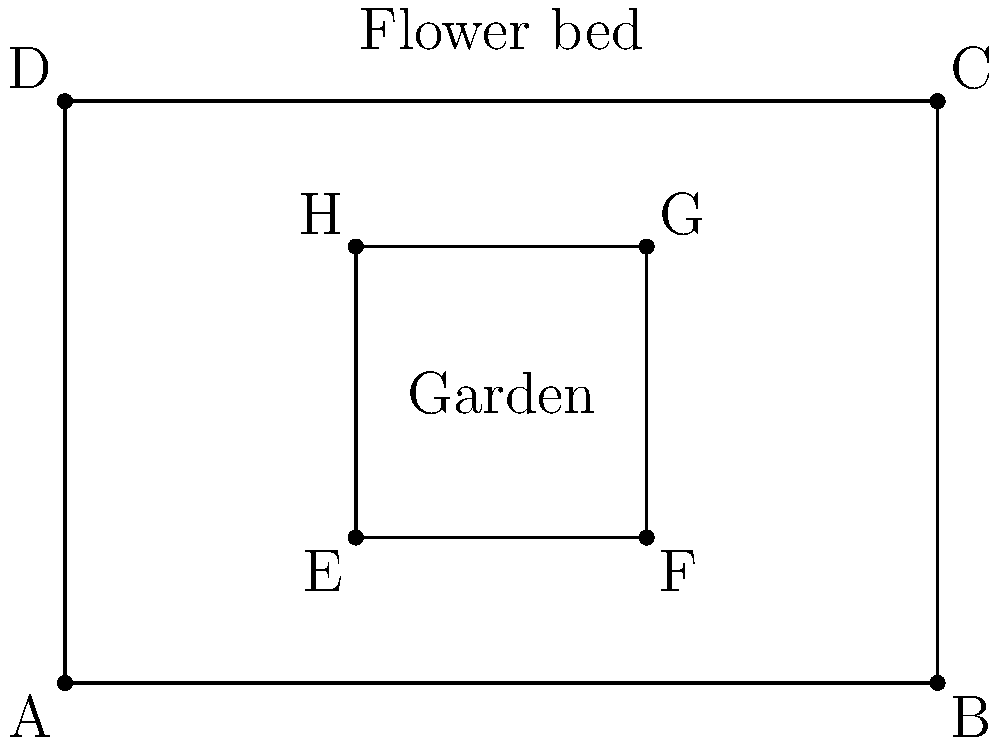In a rectangular garden ABCD, you've designed a raised flower bed EFGH to maximize sunlight exposure. If the garden measures 6m by 4m and the flower bed is centered with a 2m buffer on all sides, what percentage of the garden's area does the flower bed occupy? How might this arrangement help optimize plant growth and create a visually appealing garden layout? Let's approach this step-by-step:

1. Calculate the area of the garden:
   Area of ABCD = $6\text{m} \times 4\text{m} = 24\text{m}^2$

2. Calculate the dimensions of the flower bed:
   Length of EF = $6\text{m} - 2\text{m} - 2\text{m} = 2\text{m}$
   Width of EH = $4\text{m} - 2\text{m} - 2\text{m} = 2\text{m}$

3. Calculate the area of the flower bed:
   Area of EFGH = $2\text{m} \times 2\text{m} = 4\text{m}^2$

4. Calculate the percentage of the garden occupied by the flower bed:
   Percentage = $\frac{\text{Area of flower bed}}{\text{Area of garden}} \times 100\%$
               = $\frac{4\text{m}^2}{24\text{m}^2} \times 100\% = \frac{1}{6} \times 100\% = 16.67\%$

This arrangement optimizes plant growth and creates an appealing layout by:
1. Providing a 2m buffer around the flower bed, allowing easy access for maintenance.
2. Centralizing the flower bed to ensure equal sunlight distribution throughout the day.
3. Creating a focal point in the garden, drawing attention to the flowers.
4. Leaving space around the flower bed for pathways or additional features like seating areas.
5. Allowing for efficient use of resources by concentrating plants in a dedicated area.

This design demonstrates how we can find a silver lining in the challenge of limited garden space by creating an efficient and attractive layout that maximizes plant growth potential.
Answer: 16.67% of the garden; centralized for equal sunlight, easy maintenance, and visual appeal 